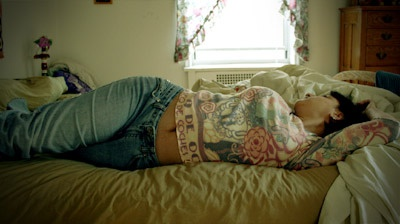Describe the objects in this image and their specific colors. I can see people in black, olive, and darkgreen tones, bed in black and olive tones, bed in black, darkgreen, and olive tones, chair in black, olive, and maroon tones, and vase in black, darkgreen, and olive tones in this image. 